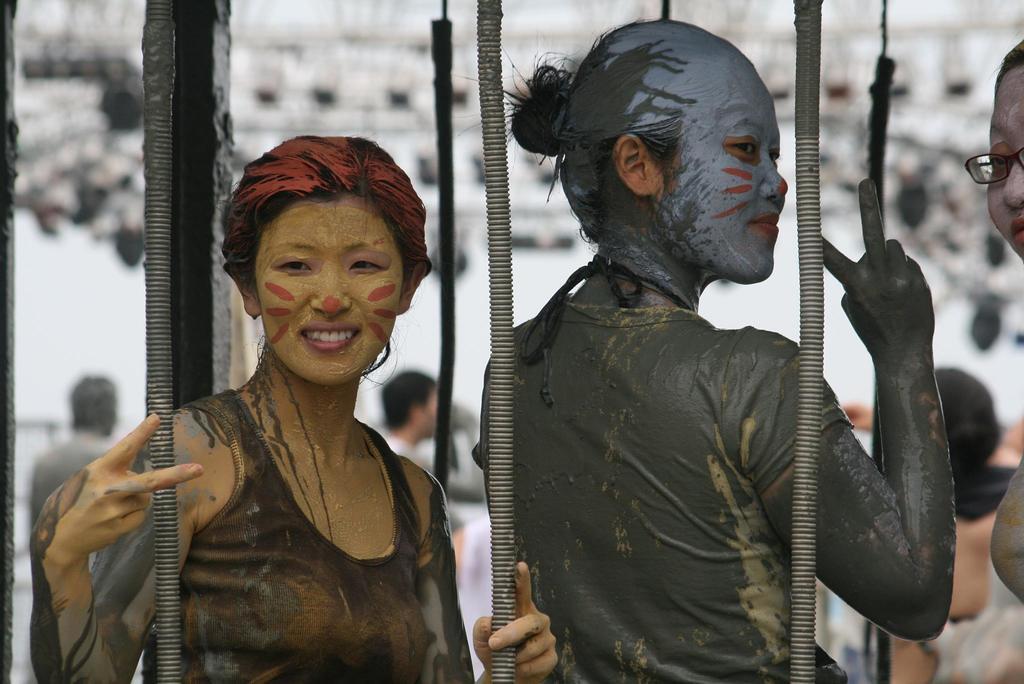Please provide a concise description of this image. In the center of the image we can see two people standing. They are dressed in costumes and we can see face painting on their faces. In the background there are people. At the bottom there are pipes. 